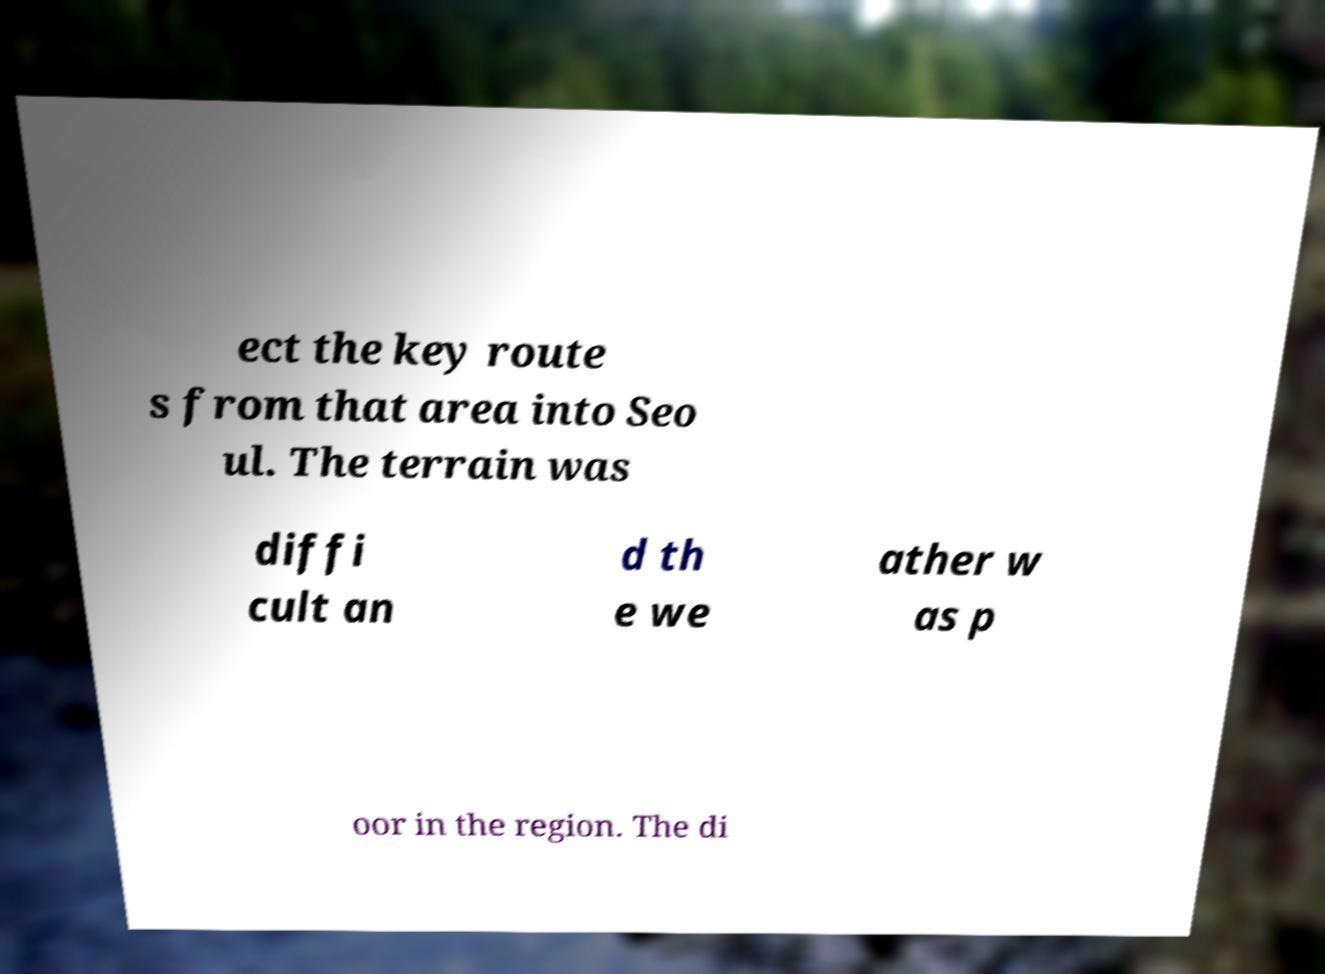Please read and relay the text visible in this image. What does it say? ect the key route s from that area into Seo ul. The terrain was diffi cult an d th e we ather w as p oor in the region. The di 